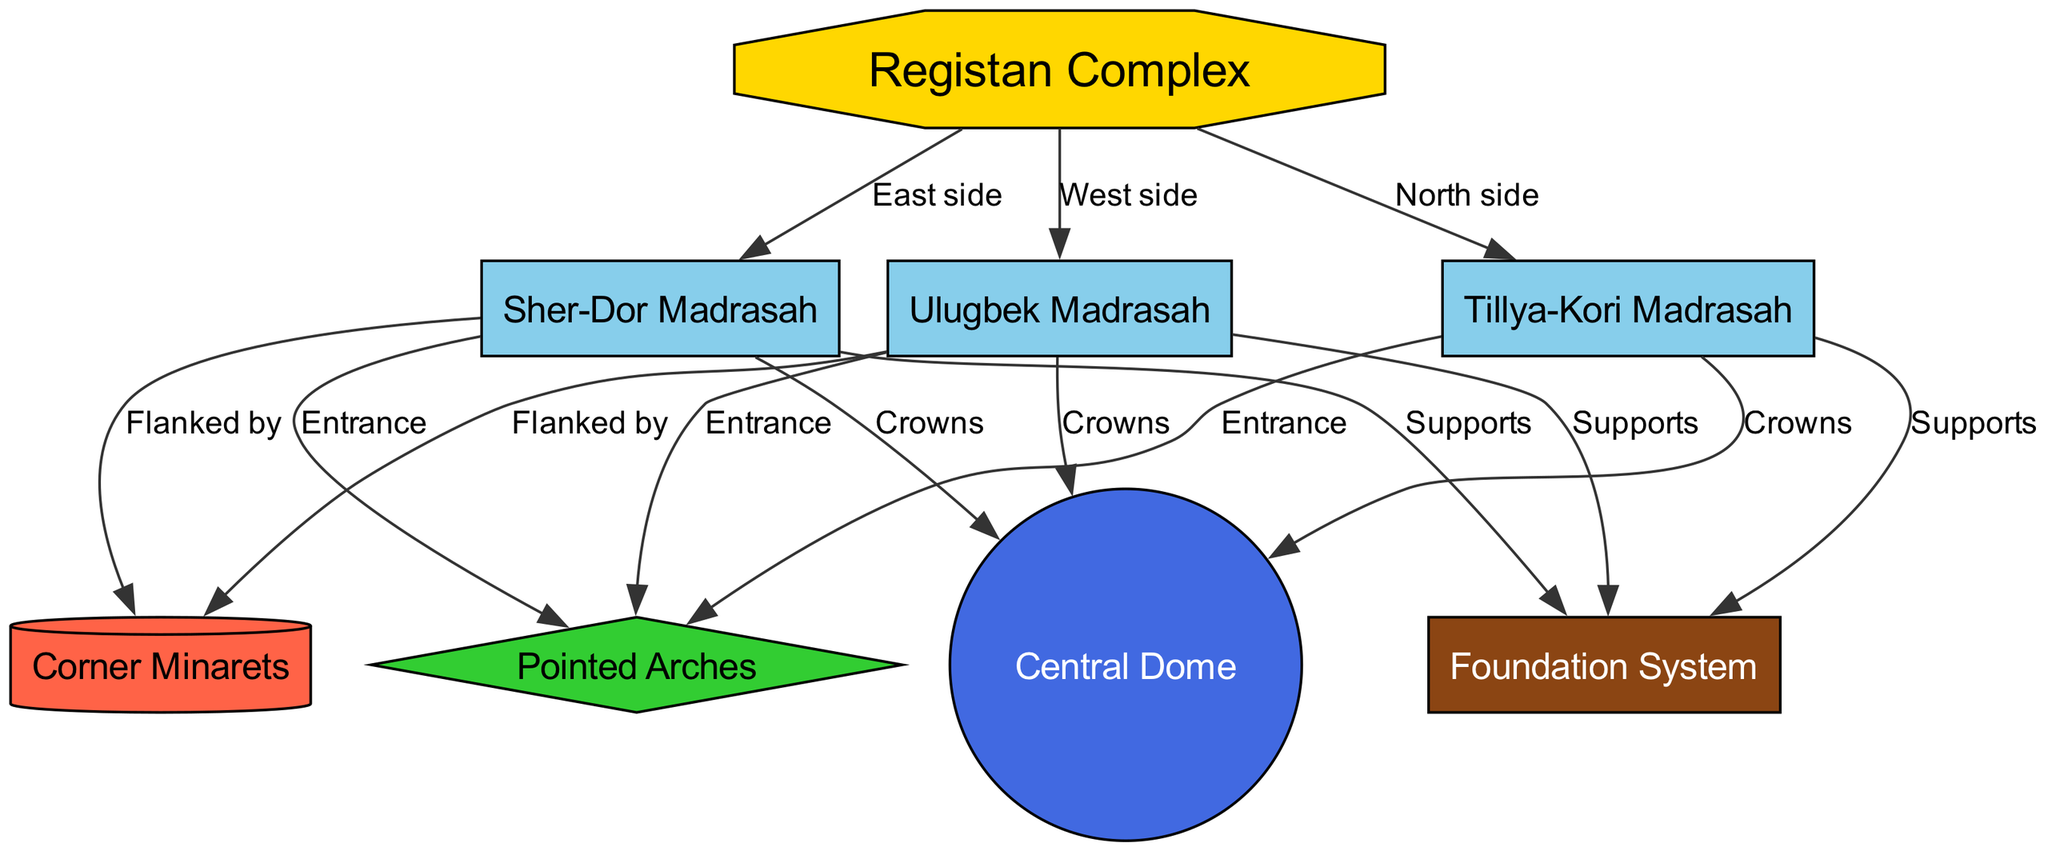What are the three madrasahs in the Registan Complex? The diagram lists Ulugbek Madrasah, Sher-Dor Madrasah, and Tillya-Kori Madrasah as nodes under the Registan Complex, indicating their presence within the complex.
Answer: Ulugbek Madrasah, Sher-Dor Madrasah, Tillya-Kori Madrasah How many edges are connected to the foundation system? By examining the diagram, we see that the foundation system has three edges connecting it to Ulugbek, Sher-Dor, and Tillya-Kori madrasahs, representing the supports.
Answer: 3 Which architectural feature crowns the Ulugbek Madrasah? The diagram explicitly shows that Ulugbek Madrasah is connected to the Central Dome via a crowning relationship, indicating the Central Dome as the feature that crowns it.
Answer: Central Dome What do the pointed arches represent in this diagram? The diagram illustrates that the pointed arches are connected to each of the three madrasahs (Ulugbek, Sher-Dor, and Tillya-Kori) through an entrance relationship, indicating their function in the architectural design.
Answer: Entrance What color represents the corner minarets in the diagram? Upon checking the color assigned to the corner minarets in the diagram, we see that it is represented using a red color (FF6347).
Answer: Red 